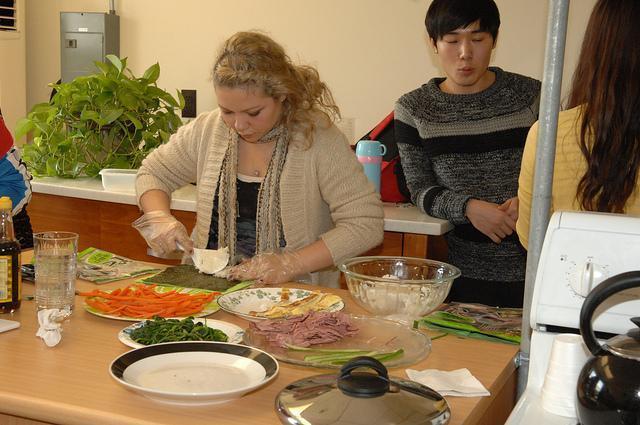How many women are in this picture?
Give a very brief answer. 2. How many empty glasses are on the table?
Give a very brief answer. 1. How many glass objects?
Give a very brief answer. 3. How many people are in the picture?
Give a very brief answer. 4. How many potted plants are there?
Give a very brief answer. 1. 